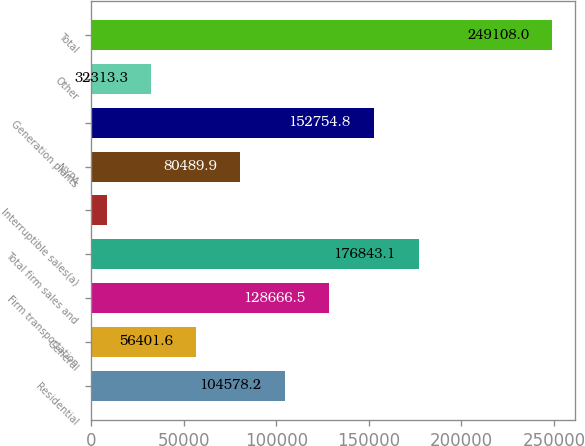Convert chart to OTSL. <chart><loc_0><loc_0><loc_500><loc_500><bar_chart><fcel>Residential<fcel>General<fcel>Firm transportation<fcel>Total firm sales and<fcel>Interruptible sales(a)<fcel>NYPA<fcel>Generation plants<fcel>Other<fcel>Total<nl><fcel>104578<fcel>56401.6<fcel>128666<fcel>176843<fcel>8225<fcel>80489.9<fcel>152755<fcel>32313.3<fcel>249108<nl></chart> 